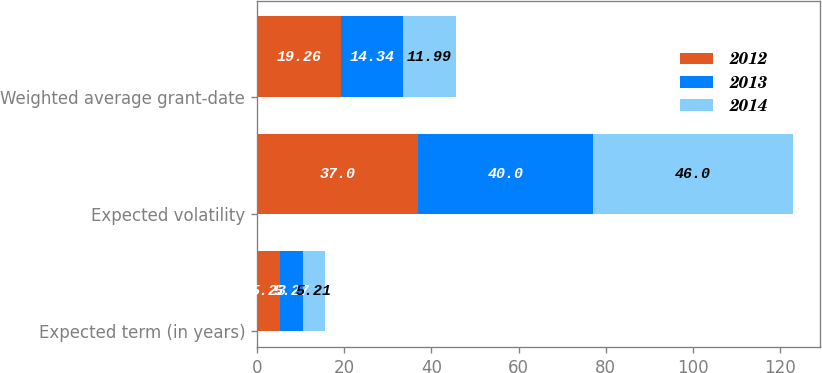<chart> <loc_0><loc_0><loc_500><loc_500><stacked_bar_chart><ecel><fcel>Expected term (in years)<fcel>Expected volatility<fcel>Weighted average grant-date<nl><fcel>2012<fcel>5.23<fcel>37<fcel>19.26<nl><fcel>2013<fcel>5.27<fcel>40<fcel>14.34<nl><fcel>2014<fcel>5.21<fcel>46<fcel>11.99<nl></chart> 